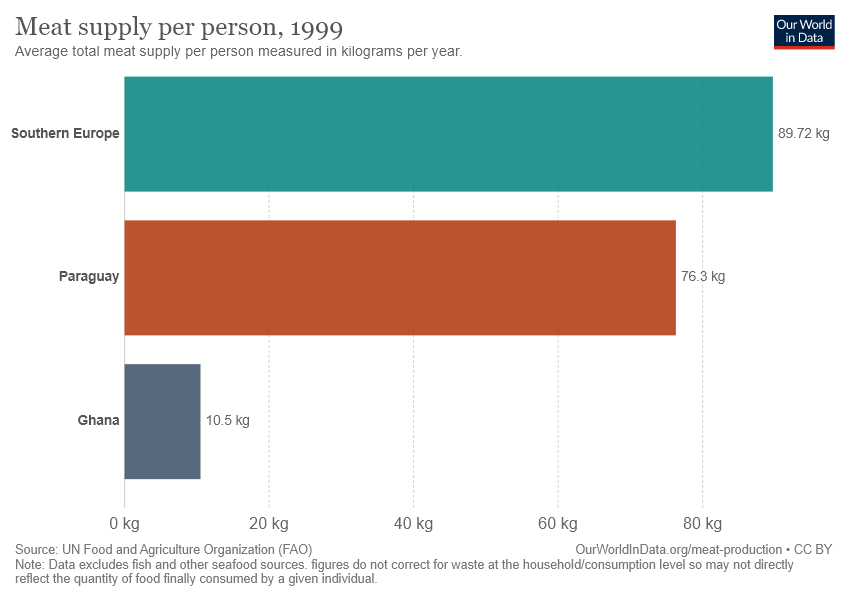What is average total meat supply per person in Ghana? According to the chart, the average total meat supply per person in Ghana in 1999 was 10.5 kilograms per year. This figure specifically refers to the meat available for consumption on average for each person and does not account for waste at the household or consumption level, so the actual amount consumed may be different. 